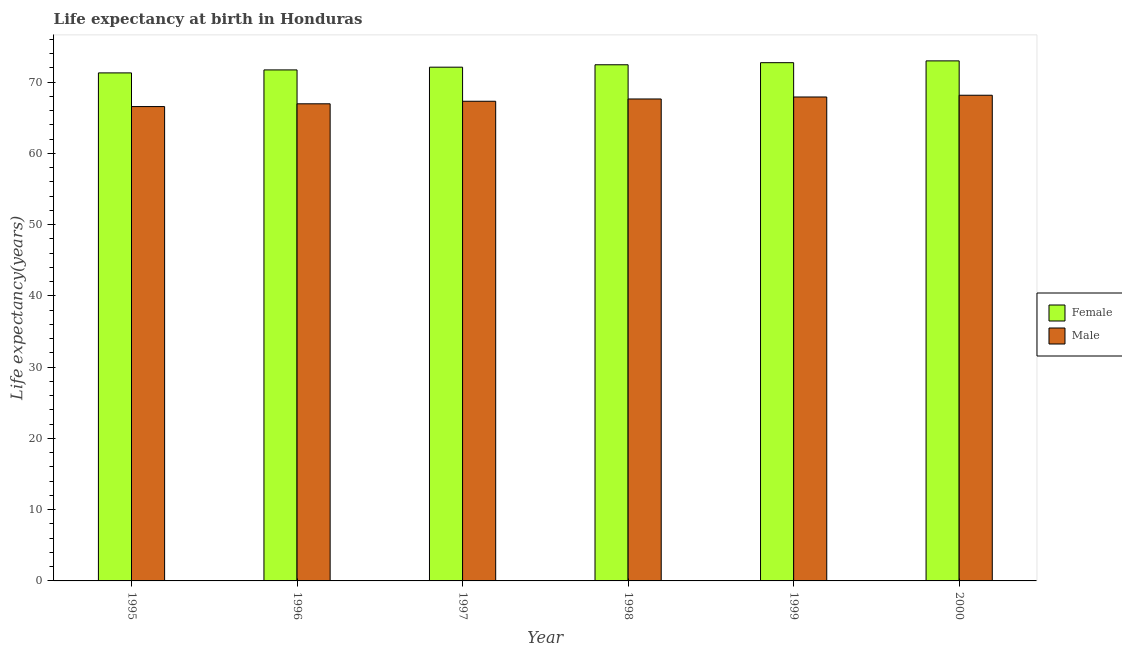How many different coloured bars are there?
Provide a short and direct response. 2. Are the number of bars per tick equal to the number of legend labels?
Offer a very short reply. Yes. Are the number of bars on each tick of the X-axis equal?
Your response must be concise. Yes. How many bars are there on the 4th tick from the left?
Provide a succinct answer. 2. In how many cases, is the number of bars for a given year not equal to the number of legend labels?
Give a very brief answer. 0. What is the life expectancy(female) in 1995?
Ensure brevity in your answer.  71.28. Across all years, what is the maximum life expectancy(female)?
Give a very brief answer. 72.96. Across all years, what is the minimum life expectancy(male)?
Ensure brevity in your answer.  66.55. In which year was the life expectancy(male) maximum?
Ensure brevity in your answer.  2000. What is the total life expectancy(male) in the graph?
Offer a terse response. 404.45. What is the difference between the life expectancy(male) in 1997 and that in 1999?
Make the answer very short. -0.6. What is the difference between the life expectancy(male) in 2000 and the life expectancy(female) in 1997?
Your response must be concise. 0.84. What is the average life expectancy(male) per year?
Provide a succinct answer. 67.41. In how many years, is the life expectancy(male) greater than 10 years?
Your answer should be very brief. 6. What is the ratio of the life expectancy(male) in 1998 to that in 1999?
Your answer should be very brief. 1. Is the difference between the life expectancy(male) in 1998 and 2000 greater than the difference between the life expectancy(female) in 1998 and 2000?
Provide a succinct answer. No. What is the difference between the highest and the second highest life expectancy(male)?
Provide a short and direct response. 0.24. What is the difference between the highest and the lowest life expectancy(female)?
Keep it short and to the point. 1.69. In how many years, is the life expectancy(male) greater than the average life expectancy(male) taken over all years?
Your response must be concise. 3. Is the sum of the life expectancy(male) in 1998 and 1999 greater than the maximum life expectancy(female) across all years?
Your response must be concise. Yes. What is the difference between two consecutive major ticks on the Y-axis?
Your response must be concise. 10. Are the values on the major ticks of Y-axis written in scientific E-notation?
Ensure brevity in your answer.  No. Does the graph contain any zero values?
Give a very brief answer. No. Does the graph contain grids?
Offer a very short reply. No. How many legend labels are there?
Offer a very short reply. 2. How are the legend labels stacked?
Offer a very short reply. Vertical. What is the title of the graph?
Your answer should be compact. Life expectancy at birth in Honduras. What is the label or title of the Y-axis?
Give a very brief answer. Life expectancy(years). What is the Life expectancy(years) of Female in 1995?
Ensure brevity in your answer.  71.28. What is the Life expectancy(years) of Male in 1995?
Make the answer very short. 66.55. What is the Life expectancy(years) of Female in 1996?
Make the answer very short. 71.7. What is the Life expectancy(years) in Male in 1996?
Provide a succinct answer. 66.94. What is the Life expectancy(years) of Female in 1997?
Make the answer very short. 72.08. What is the Life expectancy(years) in Male in 1997?
Provide a succinct answer. 67.3. What is the Life expectancy(years) of Female in 1998?
Provide a short and direct response. 72.42. What is the Life expectancy(years) in Male in 1998?
Give a very brief answer. 67.62. What is the Life expectancy(years) in Female in 1999?
Your response must be concise. 72.71. What is the Life expectancy(years) in Male in 1999?
Offer a terse response. 67.9. What is the Life expectancy(years) of Female in 2000?
Offer a terse response. 72.96. What is the Life expectancy(years) in Male in 2000?
Your answer should be very brief. 68.14. Across all years, what is the maximum Life expectancy(years) of Female?
Your response must be concise. 72.96. Across all years, what is the maximum Life expectancy(years) in Male?
Your answer should be very brief. 68.14. Across all years, what is the minimum Life expectancy(years) of Female?
Make the answer very short. 71.28. Across all years, what is the minimum Life expectancy(years) of Male?
Offer a terse response. 66.55. What is the total Life expectancy(years) in Female in the graph?
Make the answer very short. 433.15. What is the total Life expectancy(years) of Male in the graph?
Offer a terse response. 404.45. What is the difference between the Life expectancy(years) of Female in 1995 and that in 1996?
Ensure brevity in your answer.  -0.42. What is the difference between the Life expectancy(years) in Male in 1995 and that in 1996?
Provide a succinct answer. -0.39. What is the difference between the Life expectancy(years) of Female in 1995 and that in 1997?
Give a very brief answer. -0.8. What is the difference between the Life expectancy(years) in Male in 1995 and that in 1997?
Your answer should be compact. -0.74. What is the difference between the Life expectancy(years) in Female in 1995 and that in 1998?
Keep it short and to the point. -1.14. What is the difference between the Life expectancy(years) of Male in 1995 and that in 1998?
Provide a short and direct response. -1.06. What is the difference between the Life expectancy(years) of Female in 1995 and that in 1999?
Offer a very short reply. -1.43. What is the difference between the Life expectancy(years) of Male in 1995 and that in 1999?
Provide a short and direct response. -1.34. What is the difference between the Life expectancy(years) in Female in 1995 and that in 2000?
Your answer should be compact. -1.69. What is the difference between the Life expectancy(years) in Male in 1995 and that in 2000?
Your answer should be compact. -1.59. What is the difference between the Life expectancy(years) of Female in 1996 and that in 1997?
Provide a succinct answer. -0.38. What is the difference between the Life expectancy(years) of Male in 1996 and that in 1997?
Make the answer very short. -0.36. What is the difference between the Life expectancy(years) of Female in 1996 and that in 1998?
Provide a short and direct response. -0.72. What is the difference between the Life expectancy(years) of Male in 1996 and that in 1998?
Give a very brief answer. -0.68. What is the difference between the Life expectancy(years) of Female in 1996 and that in 1999?
Keep it short and to the point. -1.01. What is the difference between the Life expectancy(years) of Male in 1996 and that in 1999?
Make the answer very short. -0.96. What is the difference between the Life expectancy(years) in Female in 1996 and that in 2000?
Provide a short and direct response. -1.27. What is the difference between the Life expectancy(years) of Male in 1996 and that in 2000?
Your response must be concise. -1.2. What is the difference between the Life expectancy(years) in Female in 1997 and that in 1998?
Offer a very short reply. -0.34. What is the difference between the Life expectancy(years) of Male in 1997 and that in 1998?
Ensure brevity in your answer.  -0.32. What is the difference between the Life expectancy(years) of Female in 1997 and that in 1999?
Offer a very short reply. -0.63. What is the difference between the Life expectancy(years) in Male in 1997 and that in 1999?
Make the answer very short. -0.6. What is the difference between the Life expectancy(years) of Female in 1997 and that in 2000?
Offer a very short reply. -0.89. What is the difference between the Life expectancy(years) of Male in 1997 and that in 2000?
Offer a terse response. -0.84. What is the difference between the Life expectancy(years) of Female in 1998 and that in 1999?
Provide a succinct answer. -0.29. What is the difference between the Life expectancy(years) of Male in 1998 and that in 1999?
Your answer should be compact. -0.28. What is the difference between the Life expectancy(years) in Female in 1998 and that in 2000?
Ensure brevity in your answer.  -0.55. What is the difference between the Life expectancy(years) of Male in 1998 and that in 2000?
Give a very brief answer. -0.52. What is the difference between the Life expectancy(years) in Female in 1999 and that in 2000?
Provide a succinct answer. -0.25. What is the difference between the Life expectancy(years) in Male in 1999 and that in 2000?
Provide a short and direct response. -0.24. What is the difference between the Life expectancy(years) of Female in 1995 and the Life expectancy(years) of Male in 1996?
Make the answer very short. 4.34. What is the difference between the Life expectancy(years) of Female in 1995 and the Life expectancy(years) of Male in 1997?
Provide a short and direct response. 3.98. What is the difference between the Life expectancy(years) in Female in 1995 and the Life expectancy(years) in Male in 1998?
Make the answer very short. 3.66. What is the difference between the Life expectancy(years) in Female in 1995 and the Life expectancy(years) in Male in 1999?
Ensure brevity in your answer.  3.38. What is the difference between the Life expectancy(years) of Female in 1995 and the Life expectancy(years) of Male in 2000?
Your response must be concise. 3.14. What is the difference between the Life expectancy(years) of Female in 1996 and the Life expectancy(years) of Male in 1997?
Your response must be concise. 4.4. What is the difference between the Life expectancy(years) in Female in 1996 and the Life expectancy(years) in Male in 1998?
Keep it short and to the point. 4.08. What is the difference between the Life expectancy(years) of Female in 1996 and the Life expectancy(years) of Male in 1999?
Ensure brevity in your answer.  3.8. What is the difference between the Life expectancy(years) in Female in 1996 and the Life expectancy(years) in Male in 2000?
Provide a short and direct response. 3.56. What is the difference between the Life expectancy(years) of Female in 1997 and the Life expectancy(years) of Male in 1998?
Your answer should be compact. 4.46. What is the difference between the Life expectancy(years) in Female in 1997 and the Life expectancy(years) in Male in 1999?
Your response must be concise. 4.18. What is the difference between the Life expectancy(years) in Female in 1997 and the Life expectancy(years) in Male in 2000?
Ensure brevity in your answer.  3.94. What is the difference between the Life expectancy(years) in Female in 1998 and the Life expectancy(years) in Male in 1999?
Your response must be concise. 4.52. What is the difference between the Life expectancy(years) in Female in 1998 and the Life expectancy(years) in Male in 2000?
Make the answer very short. 4.28. What is the difference between the Life expectancy(years) of Female in 1999 and the Life expectancy(years) of Male in 2000?
Provide a short and direct response. 4.57. What is the average Life expectancy(years) in Female per year?
Offer a very short reply. 72.19. What is the average Life expectancy(years) of Male per year?
Your answer should be compact. 67.41. In the year 1995, what is the difference between the Life expectancy(years) of Female and Life expectancy(years) of Male?
Provide a succinct answer. 4.72. In the year 1996, what is the difference between the Life expectancy(years) of Female and Life expectancy(years) of Male?
Keep it short and to the point. 4.75. In the year 1997, what is the difference between the Life expectancy(years) of Female and Life expectancy(years) of Male?
Your answer should be very brief. 4.78. In the year 1998, what is the difference between the Life expectancy(years) of Female and Life expectancy(years) of Male?
Keep it short and to the point. 4.8. In the year 1999, what is the difference between the Life expectancy(years) in Female and Life expectancy(years) in Male?
Your response must be concise. 4.81. In the year 2000, what is the difference between the Life expectancy(years) of Female and Life expectancy(years) of Male?
Provide a short and direct response. 4.82. What is the ratio of the Life expectancy(years) in Female in 1995 to that in 1997?
Give a very brief answer. 0.99. What is the ratio of the Life expectancy(years) of Male in 1995 to that in 1997?
Provide a short and direct response. 0.99. What is the ratio of the Life expectancy(years) in Female in 1995 to that in 1998?
Your response must be concise. 0.98. What is the ratio of the Life expectancy(years) in Male in 1995 to that in 1998?
Provide a succinct answer. 0.98. What is the ratio of the Life expectancy(years) of Female in 1995 to that in 1999?
Your answer should be compact. 0.98. What is the ratio of the Life expectancy(years) in Male in 1995 to that in 1999?
Provide a succinct answer. 0.98. What is the ratio of the Life expectancy(years) in Female in 1995 to that in 2000?
Ensure brevity in your answer.  0.98. What is the ratio of the Life expectancy(years) in Male in 1995 to that in 2000?
Offer a very short reply. 0.98. What is the ratio of the Life expectancy(years) in Female in 1996 to that in 1997?
Give a very brief answer. 0.99. What is the ratio of the Life expectancy(years) of Male in 1996 to that in 1997?
Ensure brevity in your answer.  0.99. What is the ratio of the Life expectancy(years) of Female in 1996 to that in 1998?
Provide a succinct answer. 0.99. What is the ratio of the Life expectancy(years) of Male in 1996 to that in 1998?
Your response must be concise. 0.99. What is the ratio of the Life expectancy(years) of Female in 1996 to that in 1999?
Offer a very short reply. 0.99. What is the ratio of the Life expectancy(years) of Male in 1996 to that in 1999?
Make the answer very short. 0.99. What is the ratio of the Life expectancy(years) in Female in 1996 to that in 2000?
Ensure brevity in your answer.  0.98. What is the ratio of the Life expectancy(years) in Male in 1996 to that in 2000?
Your answer should be compact. 0.98. What is the ratio of the Life expectancy(years) of Female in 1997 to that in 1998?
Make the answer very short. 1. What is the ratio of the Life expectancy(years) of Male in 1997 to that in 1998?
Your response must be concise. 1. What is the ratio of the Life expectancy(years) in Male in 1997 to that in 1999?
Give a very brief answer. 0.99. What is the ratio of the Life expectancy(years) in Female in 1997 to that in 2000?
Your response must be concise. 0.99. What is the ratio of the Life expectancy(years) in Male in 1997 to that in 2000?
Your answer should be very brief. 0.99. What is the ratio of the Life expectancy(years) in Female in 1998 to that in 1999?
Your answer should be very brief. 1. What is the ratio of the Life expectancy(years) in Male in 1999 to that in 2000?
Your response must be concise. 1. What is the difference between the highest and the second highest Life expectancy(years) in Female?
Offer a terse response. 0.25. What is the difference between the highest and the second highest Life expectancy(years) in Male?
Your answer should be compact. 0.24. What is the difference between the highest and the lowest Life expectancy(years) of Female?
Ensure brevity in your answer.  1.69. What is the difference between the highest and the lowest Life expectancy(years) of Male?
Your answer should be compact. 1.59. 